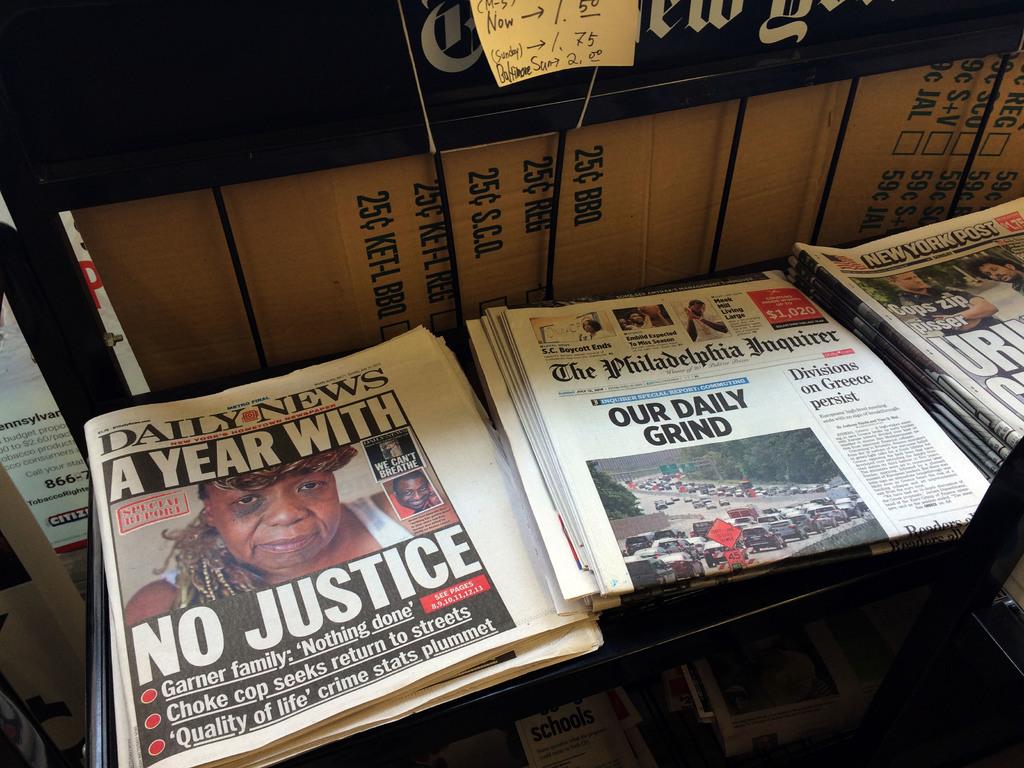What is the middle newspaper called?
Provide a short and direct response. The philadelphia inquirer. 